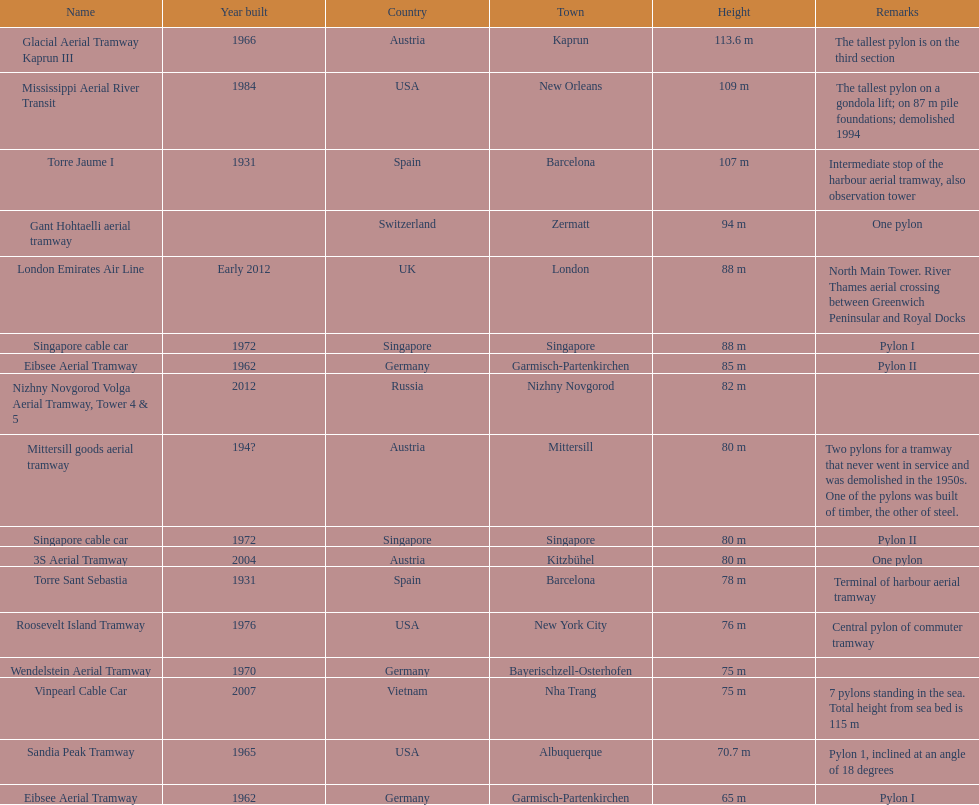List two pylons that are at most, 80 m in height. Mittersill goods aerial tramway, Singapore cable car. 